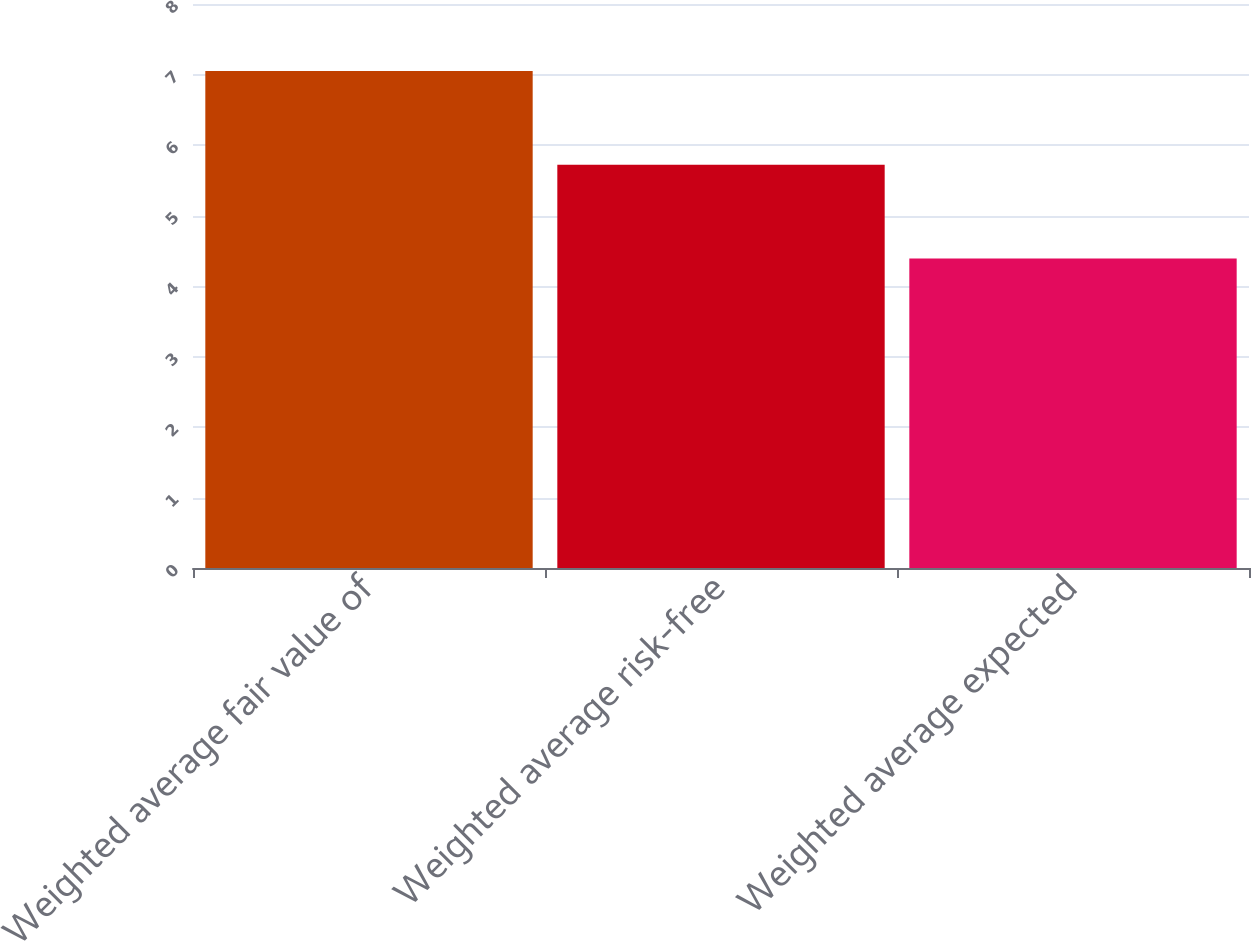<chart> <loc_0><loc_0><loc_500><loc_500><bar_chart><fcel>Weighted average fair value of<fcel>Weighted average risk-free<fcel>Weighted average expected<nl><fcel>7.05<fcel>5.72<fcel>4.39<nl></chart> 